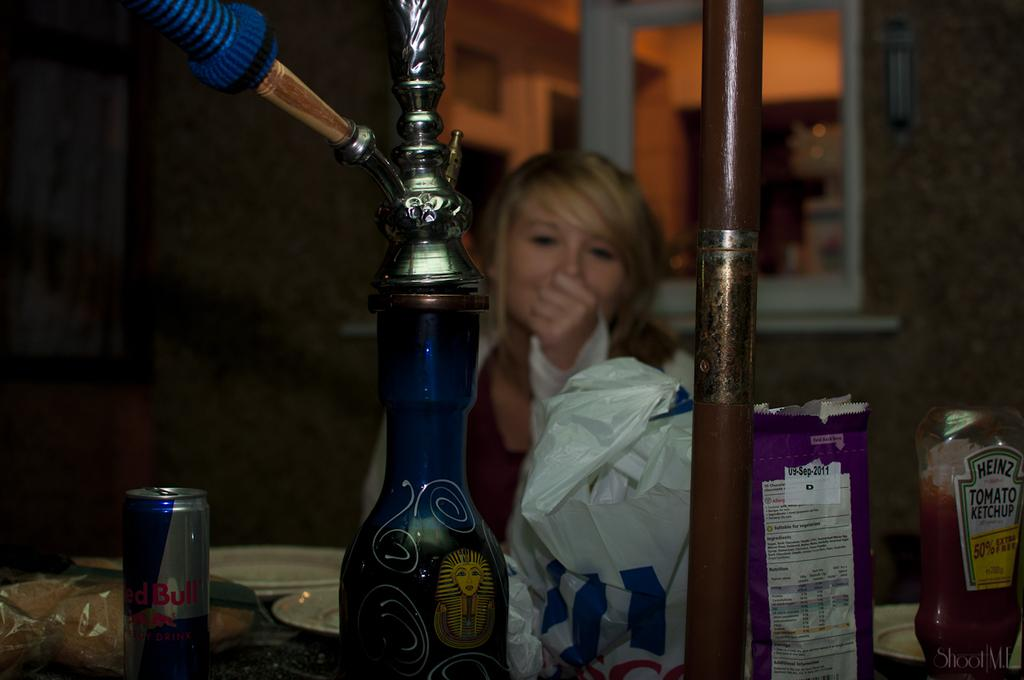<image>
Give a short and clear explanation of the subsequent image. a table with a redbull, heinz ketchup and other items 